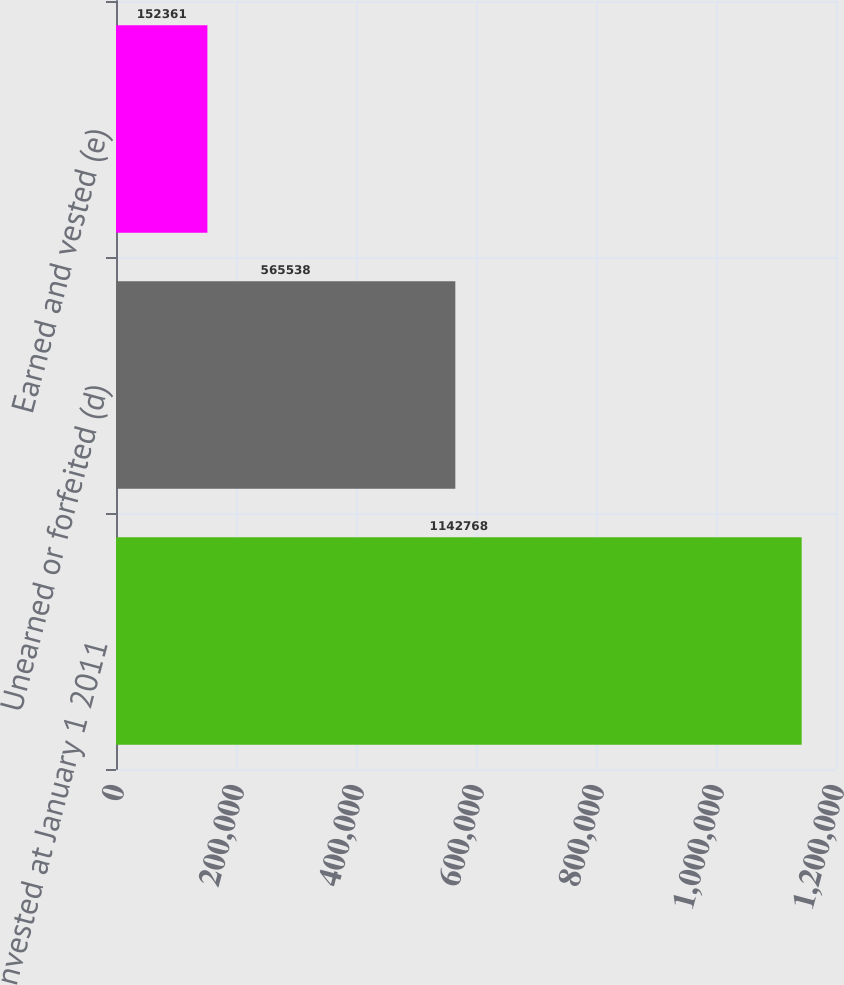Convert chart to OTSL. <chart><loc_0><loc_0><loc_500><loc_500><bar_chart><fcel>Nonvested at January 1 2011<fcel>Unearned or forfeited (d)<fcel>Earned and vested (e)<nl><fcel>1.14277e+06<fcel>565538<fcel>152361<nl></chart> 